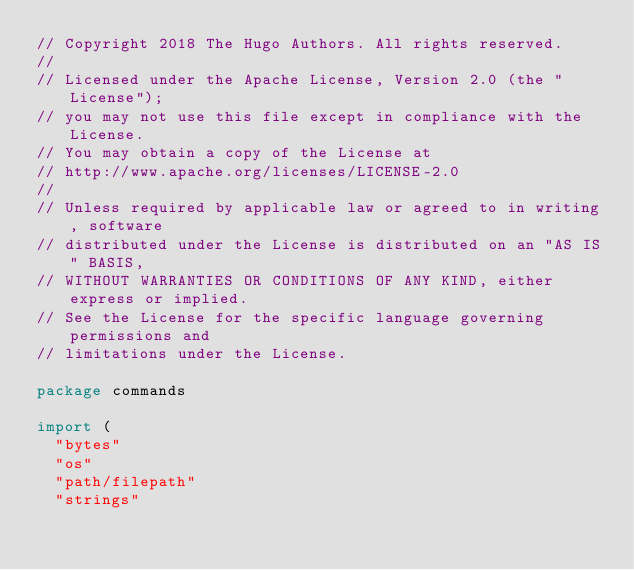Convert code to text. <code><loc_0><loc_0><loc_500><loc_500><_Go_>// Copyright 2018 The Hugo Authors. All rights reserved.
//
// Licensed under the Apache License, Version 2.0 (the "License");
// you may not use this file except in compliance with the License.
// You may obtain a copy of the License at
// http://www.apache.org/licenses/LICENSE-2.0
//
// Unless required by applicable law or agreed to in writing, software
// distributed under the License is distributed on an "AS IS" BASIS,
// WITHOUT WARRANTIES OR CONDITIONS OF ANY KIND, either express or implied.
// See the License for the specific language governing permissions and
// limitations under the License.

package commands

import (
	"bytes"
	"os"
	"path/filepath"
	"strings"
</code> 